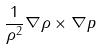Convert formula to latex. <formula><loc_0><loc_0><loc_500><loc_500>\frac { 1 } { \rho ^ { 2 } } \nabla \rho \times \nabla p</formula> 